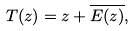Convert formula to latex. <formula><loc_0><loc_0><loc_500><loc_500>T ( z ) = z + \overline { E ( z ) } ,</formula> 